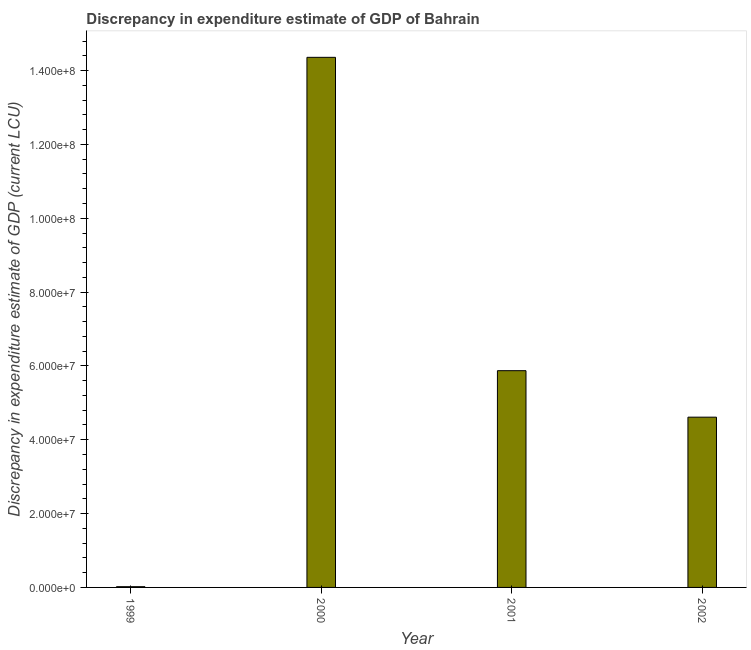Does the graph contain grids?
Keep it short and to the point. No. What is the title of the graph?
Offer a terse response. Discrepancy in expenditure estimate of GDP of Bahrain. What is the label or title of the X-axis?
Keep it short and to the point. Year. What is the label or title of the Y-axis?
Keep it short and to the point. Discrepancy in expenditure estimate of GDP (current LCU). What is the discrepancy in expenditure estimate of gdp in 2001?
Your answer should be compact. 5.87e+07. Across all years, what is the maximum discrepancy in expenditure estimate of gdp?
Provide a short and direct response. 1.44e+08. Across all years, what is the minimum discrepancy in expenditure estimate of gdp?
Your response must be concise. 2.00e+05. In which year was the discrepancy in expenditure estimate of gdp maximum?
Provide a succinct answer. 2000. What is the sum of the discrepancy in expenditure estimate of gdp?
Provide a succinct answer. 2.49e+08. What is the difference between the discrepancy in expenditure estimate of gdp in 1999 and 2002?
Your response must be concise. -4.59e+07. What is the average discrepancy in expenditure estimate of gdp per year?
Your answer should be compact. 6.22e+07. What is the median discrepancy in expenditure estimate of gdp?
Your answer should be very brief. 5.24e+07. In how many years, is the discrepancy in expenditure estimate of gdp greater than 52000000 LCU?
Provide a short and direct response. 2. Is the difference between the discrepancy in expenditure estimate of gdp in 1999 and 2002 greater than the difference between any two years?
Your answer should be very brief. No. What is the difference between the highest and the second highest discrepancy in expenditure estimate of gdp?
Your answer should be very brief. 8.49e+07. What is the difference between the highest and the lowest discrepancy in expenditure estimate of gdp?
Provide a succinct answer. 1.43e+08. How many bars are there?
Your answer should be very brief. 4. Are all the bars in the graph horizontal?
Give a very brief answer. No. How many years are there in the graph?
Your response must be concise. 4. What is the difference between two consecutive major ticks on the Y-axis?
Keep it short and to the point. 2.00e+07. Are the values on the major ticks of Y-axis written in scientific E-notation?
Your response must be concise. Yes. What is the Discrepancy in expenditure estimate of GDP (current LCU) of 1999?
Offer a terse response. 2.00e+05. What is the Discrepancy in expenditure estimate of GDP (current LCU) of 2000?
Your answer should be very brief. 1.44e+08. What is the Discrepancy in expenditure estimate of GDP (current LCU) of 2001?
Make the answer very short. 5.87e+07. What is the Discrepancy in expenditure estimate of GDP (current LCU) in 2002?
Make the answer very short. 4.61e+07. What is the difference between the Discrepancy in expenditure estimate of GDP (current LCU) in 1999 and 2000?
Make the answer very short. -1.43e+08. What is the difference between the Discrepancy in expenditure estimate of GDP (current LCU) in 1999 and 2001?
Offer a very short reply. -5.85e+07. What is the difference between the Discrepancy in expenditure estimate of GDP (current LCU) in 1999 and 2002?
Provide a short and direct response. -4.59e+07. What is the difference between the Discrepancy in expenditure estimate of GDP (current LCU) in 2000 and 2001?
Offer a very short reply. 8.49e+07. What is the difference between the Discrepancy in expenditure estimate of GDP (current LCU) in 2000 and 2002?
Your response must be concise. 9.75e+07. What is the difference between the Discrepancy in expenditure estimate of GDP (current LCU) in 2001 and 2002?
Offer a terse response. 1.26e+07. What is the ratio of the Discrepancy in expenditure estimate of GDP (current LCU) in 1999 to that in 2000?
Your answer should be compact. 0. What is the ratio of the Discrepancy in expenditure estimate of GDP (current LCU) in 1999 to that in 2001?
Your answer should be compact. 0. What is the ratio of the Discrepancy in expenditure estimate of GDP (current LCU) in 1999 to that in 2002?
Keep it short and to the point. 0. What is the ratio of the Discrepancy in expenditure estimate of GDP (current LCU) in 2000 to that in 2001?
Your response must be concise. 2.45. What is the ratio of the Discrepancy in expenditure estimate of GDP (current LCU) in 2000 to that in 2002?
Your answer should be very brief. 3.11. What is the ratio of the Discrepancy in expenditure estimate of GDP (current LCU) in 2001 to that in 2002?
Offer a very short reply. 1.27. 